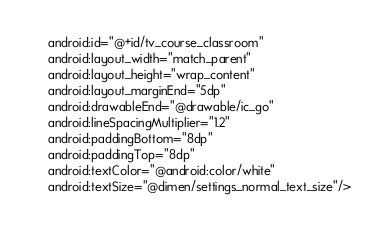Convert code to text. <code><loc_0><loc_0><loc_500><loc_500><_XML_>    android:id="@+id/tv_course_classroom"
    android:layout_width="match_parent"
    android:layout_height="wrap_content"
    android:layout_marginEnd="5dp"
    android:drawableEnd="@drawable/ic_go"
    android:lineSpacingMultiplier="1.2"
    android:paddingBottom="8dp"
    android:paddingTop="8dp"
    android:textColor="@android:color/white"
    android:textSize="@dimen/settings_normal_text_size"/></code> 